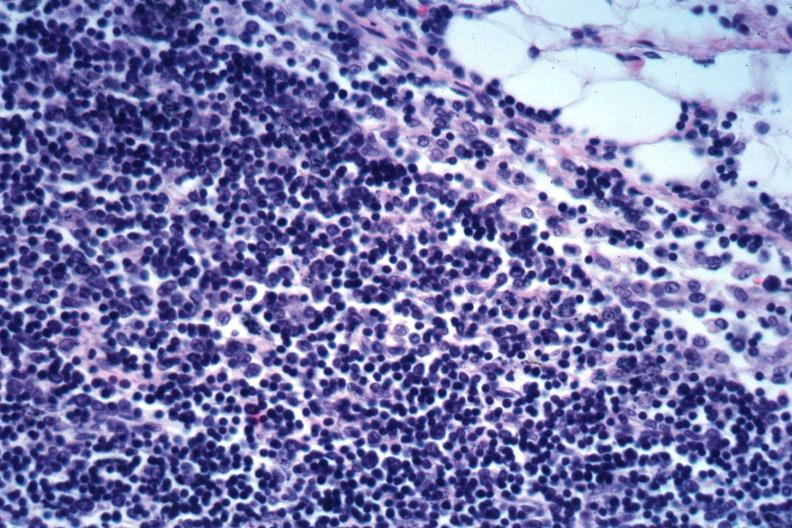what does this image show?
Answer the question using a single word or phrase. Edge of node with infiltration of capsule obliteration of subcapsular sinus mixture of small dark lymphocytes and larger cells with vesicular nuclei not specified 